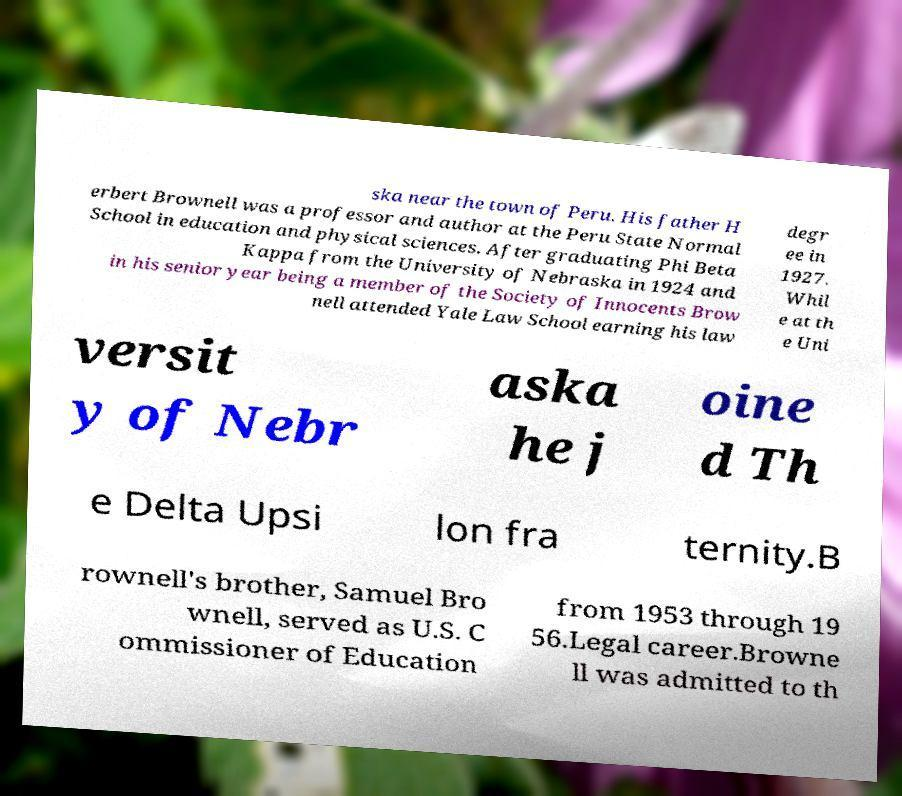Can you read and provide the text displayed in the image?This photo seems to have some interesting text. Can you extract and type it out for me? ska near the town of Peru. His father H erbert Brownell was a professor and author at the Peru State Normal School in education and physical sciences. After graduating Phi Beta Kappa from the University of Nebraska in 1924 and in his senior year being a member of the Society of Innocents Brow nell attended Yale Law School earning his law degr ee in 1927. Whil e at th e Uni versit y of Nebr aska he j oine d Th e Delta Upsi lon fra ternity.B rownell's brother, Samuel Bro wnell, served as U.S. C ommissioner of Education from 1953 through 19 56.Legal career.Browne ll was admitted to th 